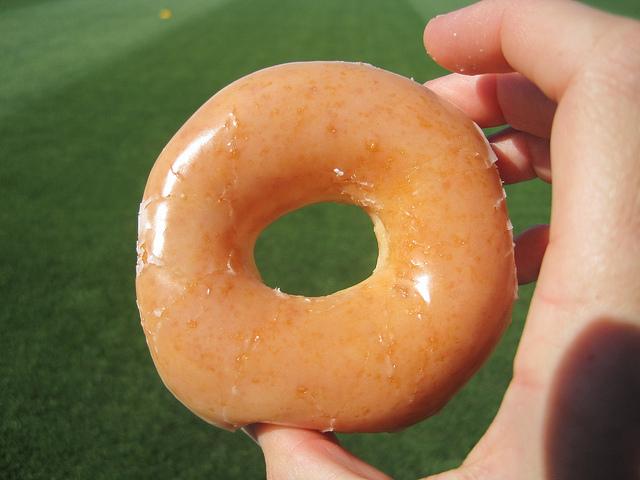Where might an Orion slave girl place this on a human?
Quick response, please. Finger. Does this doughnut have a hole?
Quick response, please. Yes. What kind of donut is this?
Concise answer only. Glazed. Is this a doughnut?
Answer briefly. Yes. What is on top of the donuts?
Keep it brief. Glaze. 